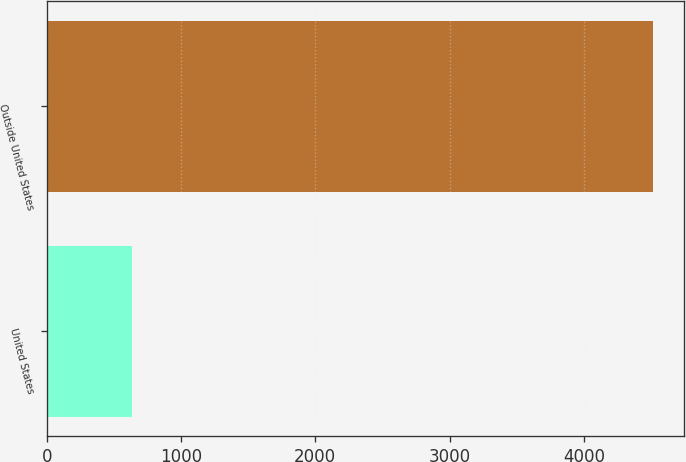Convert chart to OTSL. <chart><loc_0><loc_0><loc_500><loc_500><bar_chart><fcel>United States<fcel>Outside United States<nl><fcel>638<fcel>4518<nl></chart> 